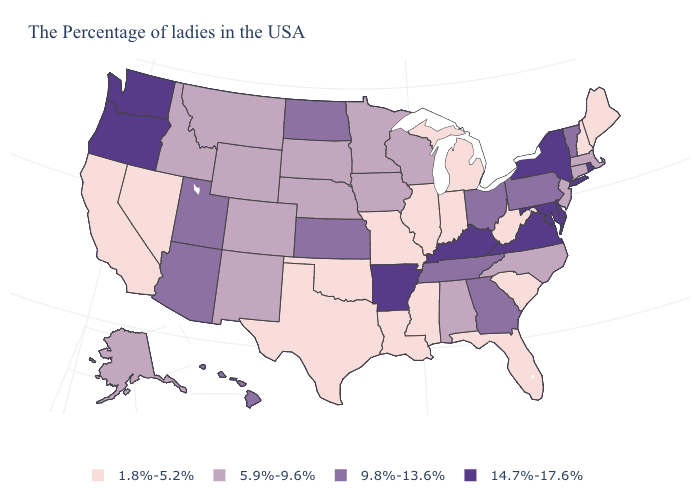What is the highest value in states that border North Dakota?
Concise answer only. 5.9%-9.6%. How many symbols are there in the legend?
Answer briefly. 4. Name the states that have a value in the range 5.9%-9.6%?
Short answer required. Massachusetts, Connecticut, New Jersey, North Carolina, Alabama, Wisconsin, Minnesota, Iowa, Nebraska, South Dakota, Wyoming, Colorado, New Mexico, Montana, Idaho, Alaska. Does Iowa have a lower value than Delaware?
Concise answer only. Yes. What is the value of Alaska?
Give a very brief answer. 5.9%-9.6%. Name the states that have a value in the range 1.8%-5.2%?
Be succinct. Maine, New Hampshire, South Carolina, West Virginia, Florida, Michigan, Indiana, Illinois, Mississippi, Louisiana, Missouri, Oklahoma, Texas, Nevada, California. Name the states that have a value in the range 1.8%-5.2%?
Short answer required. Maine, New Hampshire, South Carolina, West Virginia, Florida, Michigan, Indiana, Illinois, Mississippi, Louisiana, Missouri, Oklahoma, Texas, Nevada, California. What is the lowest value in the MidWest?
Keep it brief. 1.8%-5.2%. Among the states that border Michigan , does Ohio have the highest value?
Keep it brief. Yes. How many symbols are there in the legend?
Concise answer only. 4. What is the value of Minnesota?
Be succinct. 5.9%-9.6%. What is the value of Illinois?
Give a very brief answer. 1.8%-5.2%. What is the highest value in the USA?
Write a very short answer. 14.7%-17.6%. Does Nevada have the lowest value in the USA?
Write a very short answer. Yes. What is the value of Wyoming?
Be succinct. 5.9%-9.6%. 